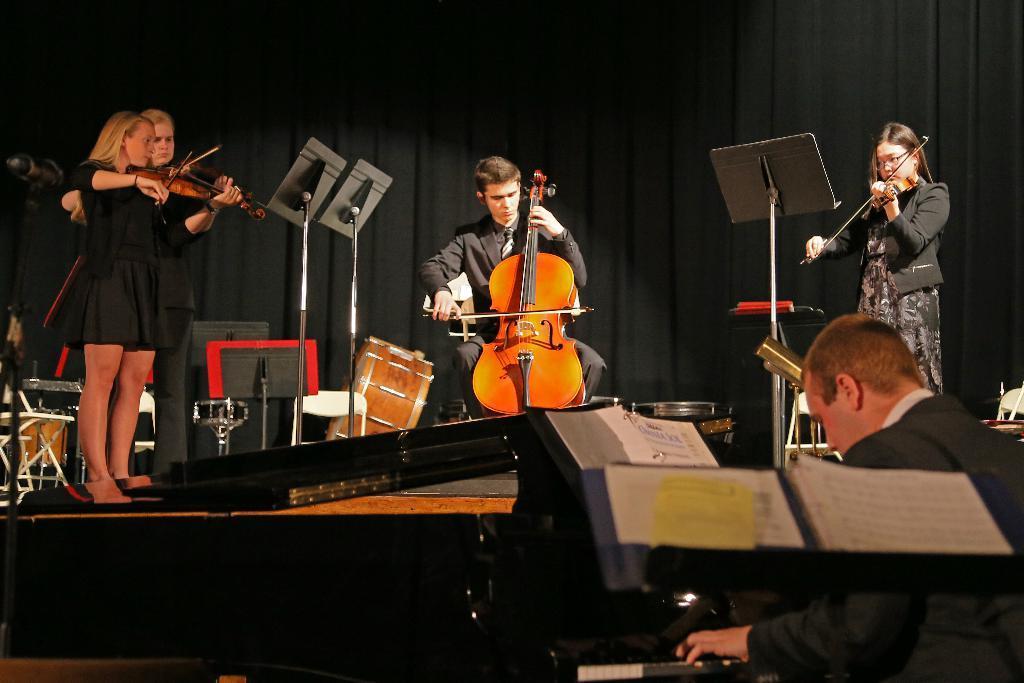How would you summarize this image in a sentence or two? In this image I can see one person is sitting on the chair and playing the violin on the stage. On the right and left side of the image there are few women standing and playing the violin. In the background I can see black color curtains. On the right corner I can see a man playing the piano. 